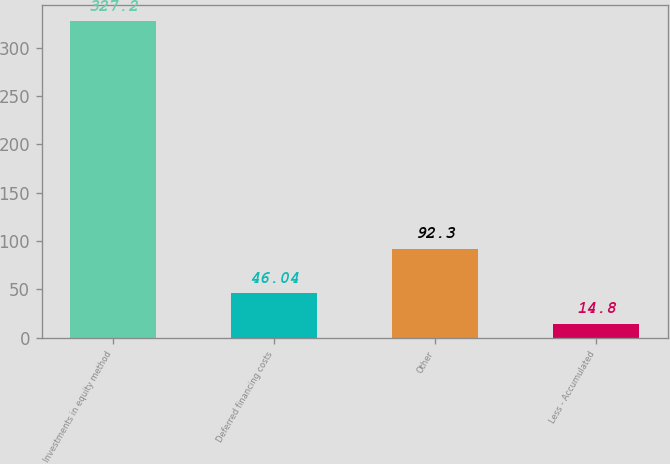Convert chart to OTSL. <chart><loc_0><loc_0><loc_500><loc_500><bar_chart><fcel>Investments in equity method<fcel>Deferred financing costs<fcel>Other<fcel>Less - Accumulated<nl><fcel>327.2<fcel>46.04<fcel>92.3<fcel>14.8<nl></chart> 